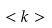<formula> <loc_0><loc_0><loc_500><loc_500>< k ></formula> 